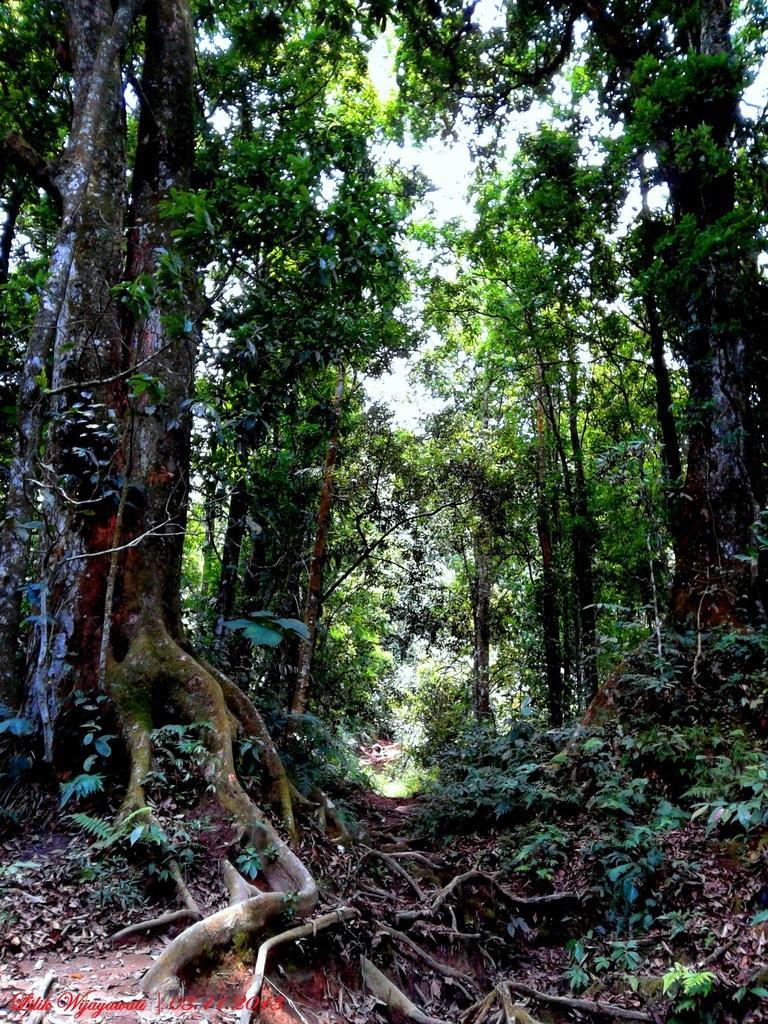Can you describe this image briefly? In this picture we can see some trees and some dry leaves are on the surface. 